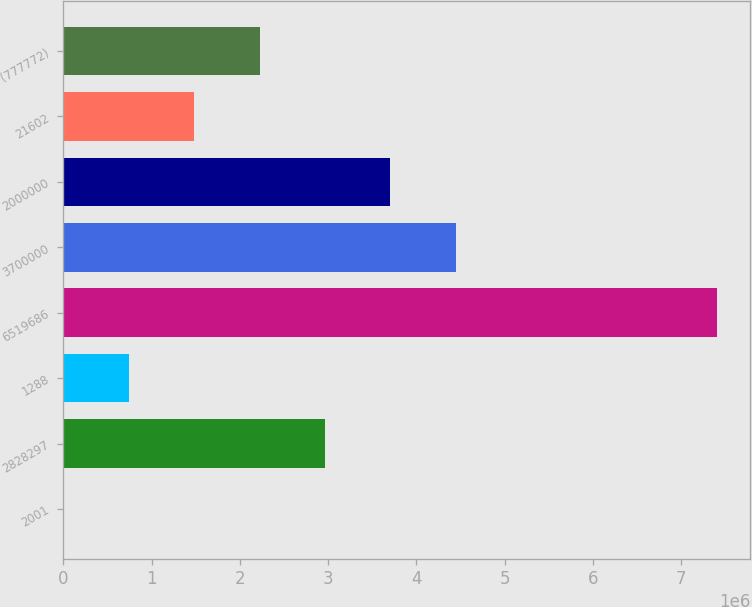Convert chart to OTSL. <chart><loc_0><loc_0><loc_500><loc_500><bar_chart><fcel>2001<fcel>2828297<fcel>1288<fcel>6519686<fcel>3700000<fcel>2000000<fcel>21602<fcel>(777772)<nl><fcel>2005<fcel>2.96529e+06<fcel>742826<fcel>7.41021e+06<fcel>4.44693e+06<fcel>3.70611e+06<fcel>1.48365e+06<fcel>2.22447e+06<nl></chart> 